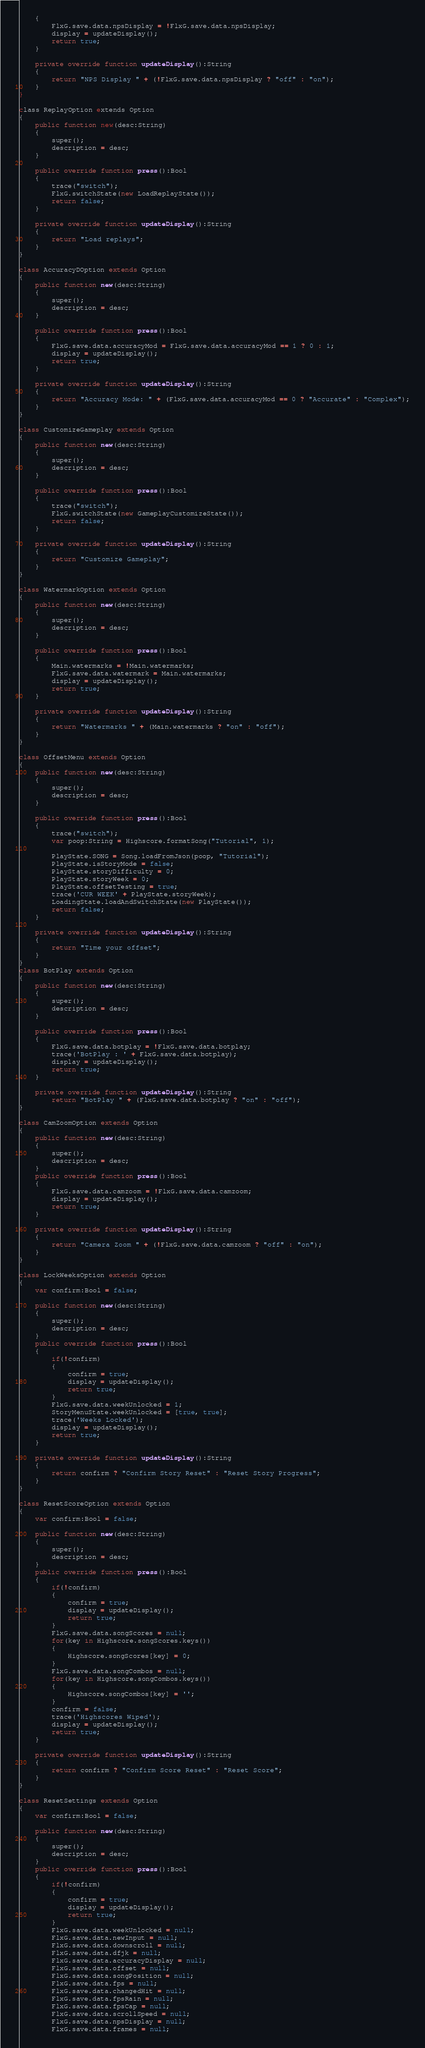<code> <loc_0><loc_0><loc_500><loc_500><_Haxe_>	{
		FlxG.save.data.npsDisplay = !FlxG.save.data.npsDisplay;
		display = updateDisplay();
		return true;
	}

	private override function updateDisplay():String
	{
		return "NPS Display " + (!FlxG.save.data.npsDisplay ? "off" : "on");
	}
}

class ReplayOption extends Option
{
	public function new(desc:String)
	{
		super();
		description = desc;
	}
	
	public override function press():Bool
	{
		trace("switch");
		FlxG.switchState(new LoadReplayState());
		return false;
	}

	private override function updateDisplay():String
	{
		return "Load replays";
	}
}

class AccuracyDOption extends Option
{
	public function new(desc:String)
	{
		super();
		description = desc;
	}
	
	public override function press():Bool
	{
		FlxG.save.data.accuracyMod = FlxG.save.data.accuracyMod == 1 ? 0 : 1;
		display = updateDisplay();
		return true;
	}

	private override function updateDisplay():String
	{
		return "Accuracy Mode: " + (FlxG.save.data.accuracyMod == 0 ? "Accurate" : "Complex");
	}
}

class CustomizeGameplay extends Option
{
	public function new(desc:String)
	{
		super();
		description = desc;
	}

	public override function press():Bool
	{
		trace("switch");
		FlxG.switchState(new GameplayCustomizeState());
		return false;
	}

	private override function updateDisplay():String
	{
		return "Customize Gameplay";
	}
}

class WatermarkOption extends Option
{
	public function new(desc:String)
	{
		super();
		description = desc;
	}

	public override function press():Bool
	{
		Main.watermarks = !Main.watermarks;
		FlxG.save.data.watermark = Main.watermarks;
		display = updateDisplay();
		return true;
	}

	private override function updateDisplay():String
	{
		return "Watermarks " + (Main.watermarks ? "on" : "off");
	}
}

class OffsetMenu extends Option
{
	public function new(desc:String)
	{
		super();
		description = desc;
	}

	public override function press():Bool
	{
		trace("switch");
		var poop:String = Highscore.formatSong("Tutorial", 1);

		PlayState.SONG = Song.loadFromJson(poop, "Tutorial");
		PlayState.isStoryMode = false;
		PlayState.storyDifficulty = 0;
		PlayState.storyWeek = 0;
		PlayState.offsetTesting = true;
		trace('CUR WEEK' + PlayState.storyWeek);
		LoadingState.loadAndSwitchState(new PlayState());
		return false;
	}

	private override function updateDisplay():String
	{
		return "Time your offset";
	}
}
class BotPlay extends Option
{
	public function new(desc:String)
	{
		super();
		description = desc;
	}
	
	public override function press():Bool
	{
		FlxG.save.data.botplay = !FlxG.save.data.botplay;
		trace('BotPlay : ' + FlxG.save.data.botplay);
		display = updateDisplay();
		return true;
	}
	
	private override function updateDisplay():String
		return "BotPlay " + (FlxG.save.data.botplay ? "on" : "off");
}

class CamZoomOption extends Option
{
	public function new(desc:String)
	{
		super();
		description = desc;
	}
	public override function press():Bool
	{
		FlxG.save.data.camzoom = !FlxG.save.data.camzoom;
		display = updateDisplay();
		return true;
	}

	private override function updateDisplay():String
	{
		return "Camera Zoom " + (!FlxG.save.data.camzoom ? "off" : "on");
	}
}

class LockWeeksOption extends Option
{
	var confirm:Bool = false;

	public function new(desc:String)
	{
		super();
		description = desc;
	}
	public override function press():Bool
	{
		if(!confirm)
		{
			confirm = true;
			display = updateDisplay();
			return true;
		}
		FlxG.save.data.weekUnlocked = 1;
		StoryMenuState.weekUnlocked = [true, true];
		trace('Weeks Locked');
		display = updateDisplay();
		return true;
	}

	private override function updateDisplay():String
	{
		return confirm ? "Confirm Story Reset" : "Reset Story Progress";
	}
}

class ResetScoreOption extends Option
{
	var confirm:Bool = false;

	public function new(desc:String)
	{
		super();
		description = desc;
	}
	public override function press():Bool
	{
		if(!confirm)
		{
			confirm = true;
			display = updateDisplay();
			return true;
		}
		FlxG.save.data.songScores = null;
		for(key in Highscore.songScores.keys())
		{
			Highscore.songScores[key] = 0;
		}
		FlxG.save.data.songCombos = null;
		for(key in Highscore.songCombos.keys())
		{
			Highscore.songCombos[key] = '';
		}
		confirm = false;
		trace('Highscores Wiped');
		display = updateDisplay();
		return true;
	}

	private override function updateDisplay():String
	{
		return confirm ? "Confirm Score Reset" : "Reset Score";
	}
}

class ResetSettings extends Option
{
	var confirm:Bool = false;

	public function new(desc:String)
	{
		super();
		description = desc;
	}
	public override function press():Bool
	{
		if(!confirm)
		{
			confirm = true;
			display = updateDisplay();
			return true;
		}
		FlxG.save.data.weekUnlocked = null;
		FlxG.save.data.newInput = null;
		FlxG.save.data.downscroll = null;
		FlxG.save.data.dfjk = null;
		FlxG.save.data.accuracyDisplay = null;
		FlxG.save.data.offset = null;
		FlxG.save.data.songPosition = null;
		FlxG.save.data.fps = null;
		FlxG.save.data.changedHit = null;
		FlxG.save.data.fpsRain = null;
		FlxG.save.data.fpsCap = null;
		FlxG.save.data.scrollSpeed = null;
		FlxG.save.data.npsDisplay = null;
		FlxG.save.data.frames = null;</code> 